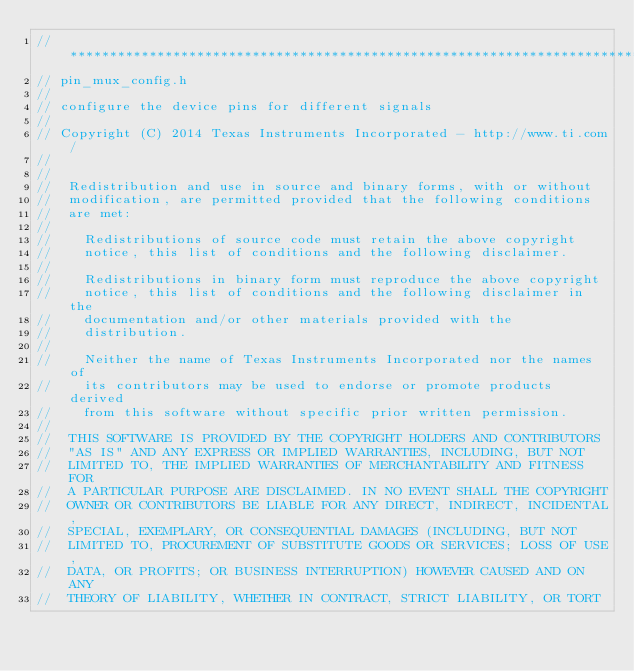<code> <loc_0><loc_0><loc_500><loc_500><_C_>//*****************************************************************************
// pin_mux_config.h
//
// configure the device pins for different signals
//
// Copyright (C) 2014 Texas Instruments Incorporated - http://www.ti.com/ 
// 
// 
//  Redistribution and use in source and binary forms, with or without 
//  modification, are permitted provided that the following conditions 
//  are met:
//
//    Redistributions of source code must retain the above copyright 
//    notice, this list of conditions and the following disclaimer.
//
//    Redistributions in binary form must reproduce the above copyright
//    notice, this list of conditions and the following disclaimer in the 
//    documentation and/or other materials provided with the   
//    distribution.
//
//    Neither the name of Texas Instruments Incorporated nor the names of
//    its contributors may be used to endorse or promote products derived
//    from this software without specific prior written permission.
//
//  THIS SOFTWARE IS PROVIDED BY THE COPYRIGHT HOLDERS AND CONTRIBUTORS 
//  "AS IS" AND ANY EXPRESS OR IMPLIED WARRANTIES, INCLUDING, BUT NOT 
//  LIMITED TO, THE IMPLIED WARRANTIES OF MERCHANTABILITY AND FITNESS FOR
//  A PARTICULAR PURPOSE ARE DISCLAIMED. IN NO EVENT SHALL THE COPYRIGHT 
//  OWNER OR CONTRIBUTORS BE LIABLE FOR ANY DIRECT, INDIRECT, INCIDENTAL, 
//  SPECIAL, EXEMPLARY, OR CONSEQUENTIAL DAMAGES (INCLUDING, BUT NOT 
//  LIMITED TO, PROCUREMENT OF SUBSTITUTE GOODS OR SERVICES; LOSS OF USE,
//  DATA, OR PROFITS; OR BUSINESS INTERRUPTION) HOWEVER CAUSED AND ON ANY
//  THEORY OF LIABILITY, WHETHER IN CONTRACT, STRICT LIABILITY, OR TORT </code> 